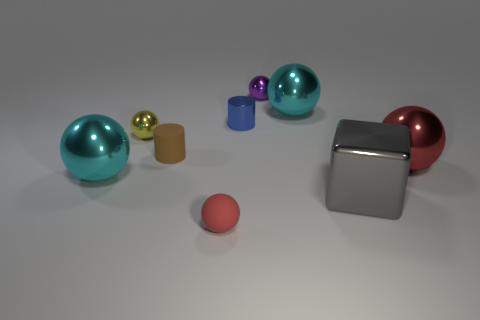Can you tell me what the largest object in the scene is? The largest object in the scene is the big cyan-colored sphere on the left side. It shows a metallic sheen, indicating it might be made of metal. 